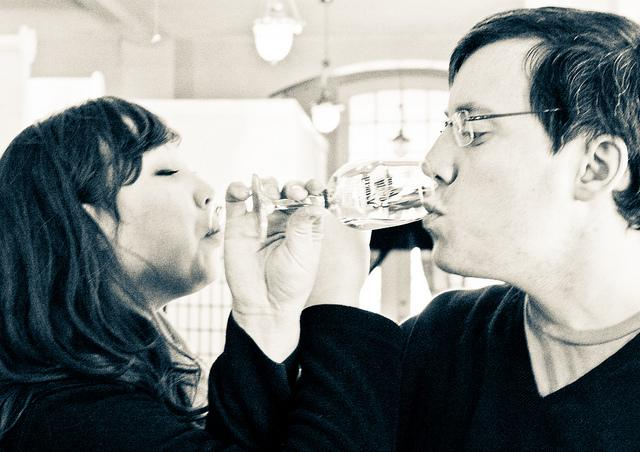What kind of beverage are the couple most likely drinking together?

Choices:
A) water
B) wine
C) beer
D) juice water 